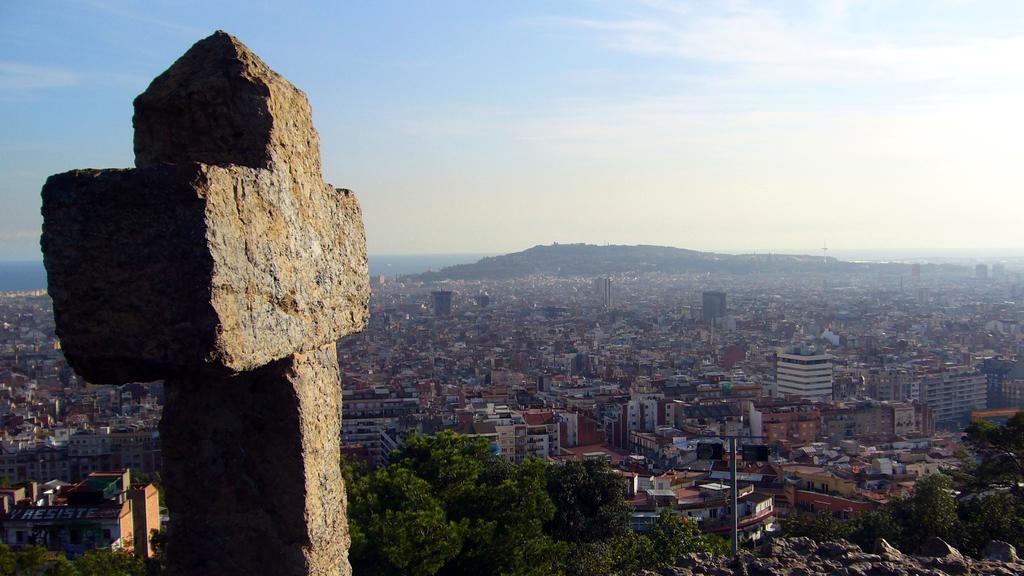Please provide a concise description of this image. In the foreground of this image, there is a stone in the shape of cross. In the background, there are trees, city, water, cliff, sky and the cloud. 